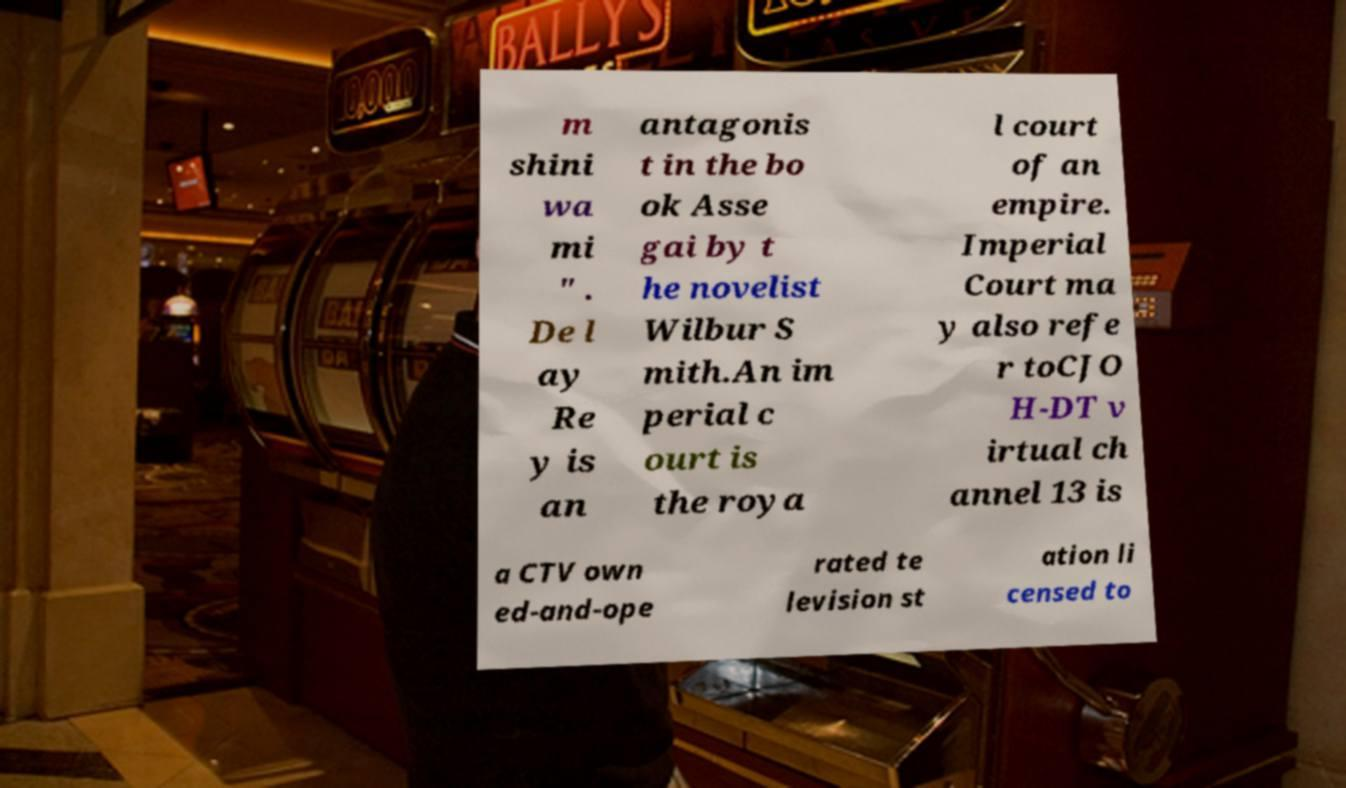I need the written content from this picture converted into text. Can you do that? m shini wa mi " . De l ay Re y is an antagonis t in the bo ok Asse gai by t he novelist Wilbur S mith.An im perial c ourt is the roya l court of an empire. Imperial Court ma y also refe r toCJO H-DT v irtual ch annel 13 is a CTV own ed-and-ope rated te levision st ation li censed to 